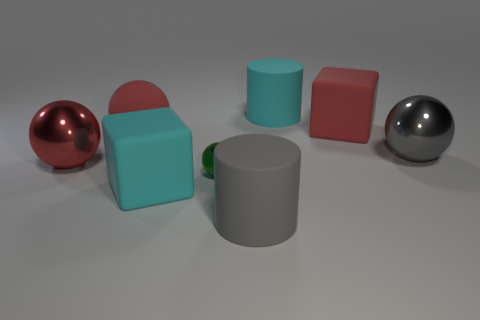What is the shape of the gray shiny object?
Offer a very short reply. Sphere. Are the big gray cylinder and the cyan cube made of the same material?
Provide a succinct answer. Yes. Are there an equal number of large gray matte cylinders that are to the left of the tiny green sphere and matte things on the right side of the cyan matte cylinder?
Keep it short and to the point. No. There is a big red matte thing that is to the right of the large cylinder in front of the big red rubber ball; are there any tiny green spheres that are behind it?
Your response must be concise. No. Does the cyan rubber cube have the same size as the red rubber ball?
Keep it short and to the point. Yes. There is a cube that is behind the cyan rubber object in front of the large cyan thing that is behind the big matte ball; what is its color?
Provide a short and direct response. Red. How many metal spheres are the same color as the big rubber ball?
Your response must be concise. 1. What number of large things are either cyan things or yellow shiny cubes?
Make the answer very short. 2. Is there another red metal thing that has the same shape as the tiny thing?
Offer a terse response. Yes. Does the tiny metal thing have the same shape as the large gray metallic thing?
Provide a short and direct response. Yes. 